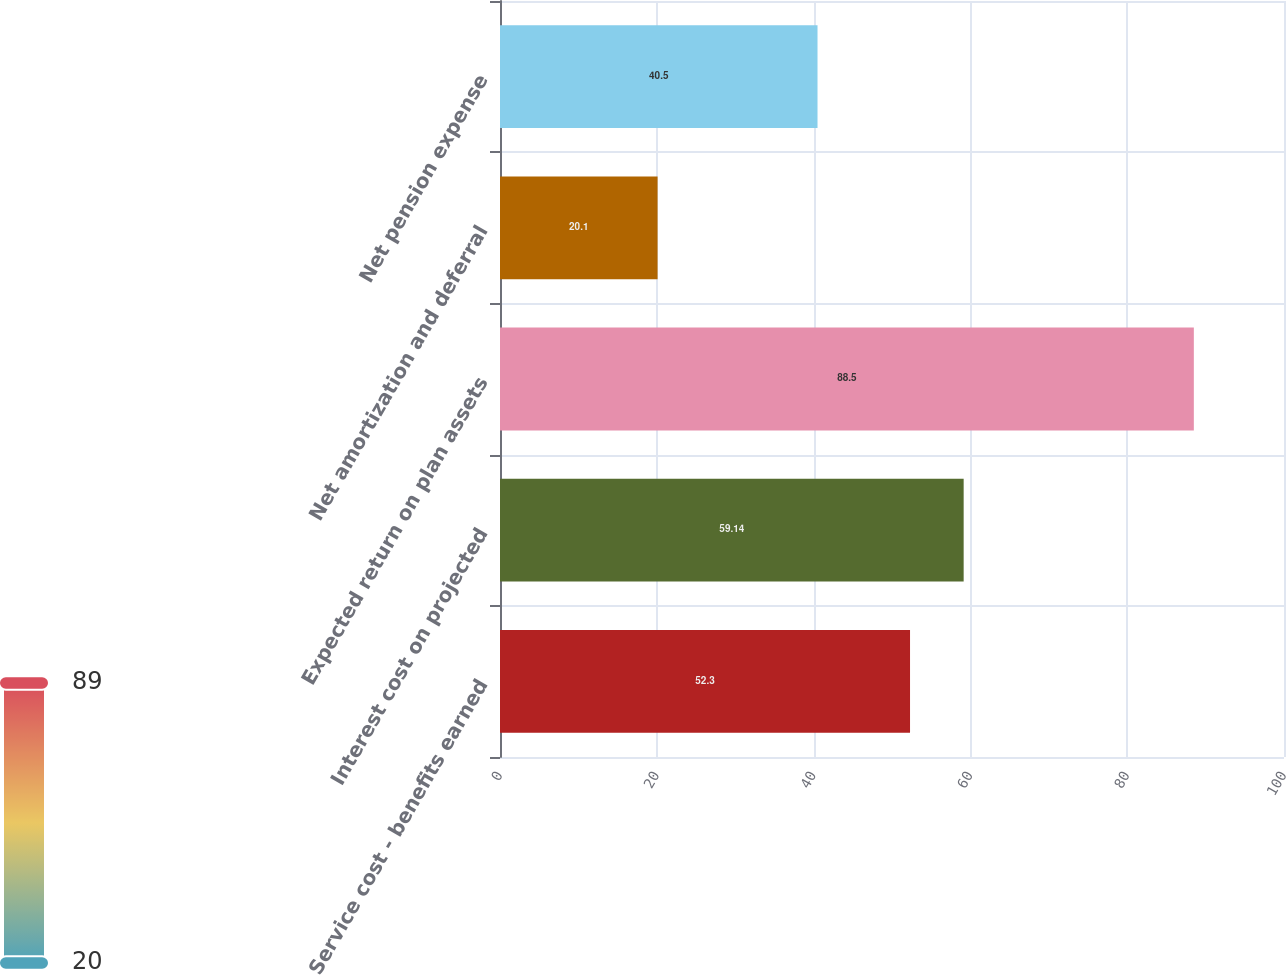Convert chart to OTSL. <chart><loc_0><loc_0><loc_500><loc_500><bar_chart><fcel>Service cost - benefits earned<fcel>Interest cost on projected<fcel>Expected return on plan assets<fcel>Net amortization and deferral<fcel>Net pension expense<nl><fcel>52.3<fcel>59.14<fcel>88.5<fcel>20.1<fcel>40.5<nl></chart> 